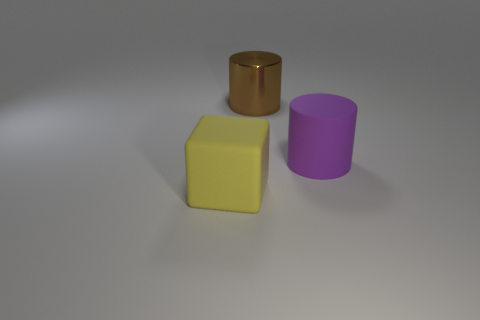Add 2 tiny cyan cubes. How many objects exist? 5 Subtract all cylinders. How many objects are left? 1 Subtract 0 gray cubes. How many objects are left? 3 Subtract all brown cylinders. Subtract all big rubber objects. How many objects are left? 0 Add 2 cubes. How many cubes are left? 3 Add 2 big matte cylinders. How many big matte cylinders exist? 3 